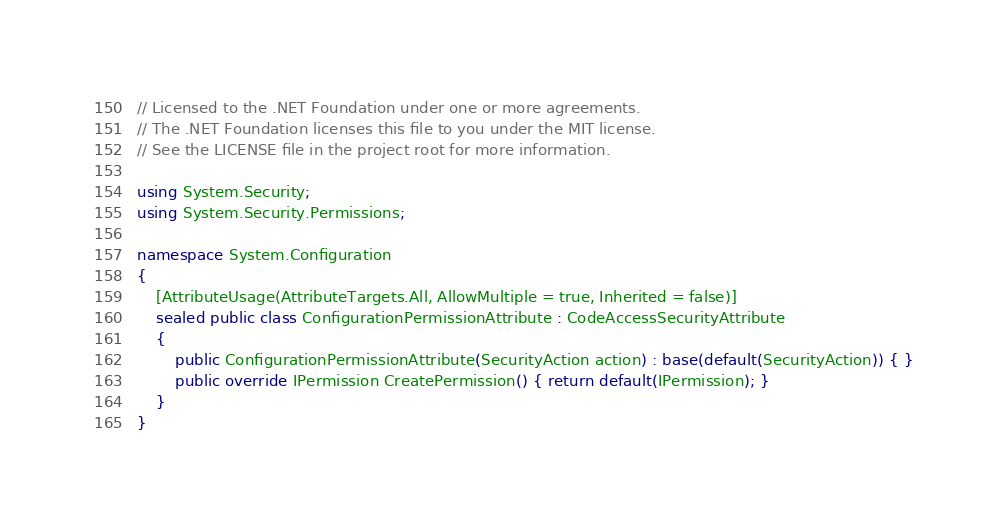<code> <loc_0><loc_0><loc_500><loc_500><_C#_>// Licensed to the .NET Foundation under one or more agreements.
// The .NET Foundation licenses this file to you under the MIT license.
// See the LICENSE file in the project root for more information.

using System.Security;
using System.Security.Permissions;

namespace System.Configuration
{
    [AttributeUsage(AttributeTargets.All, AllowMultiple = true, Inherited = false)]
    sealed public class ConfigurationPermissionAttribute : CodeAccessSecurityAttribute
    {
        public ConfigurationPermissionAttribute(SecurityAction action) : base(default(SecurityAction)) { }
        public override IPermission CreatePermission() { return default(IPermission); }
    }
}</code> 